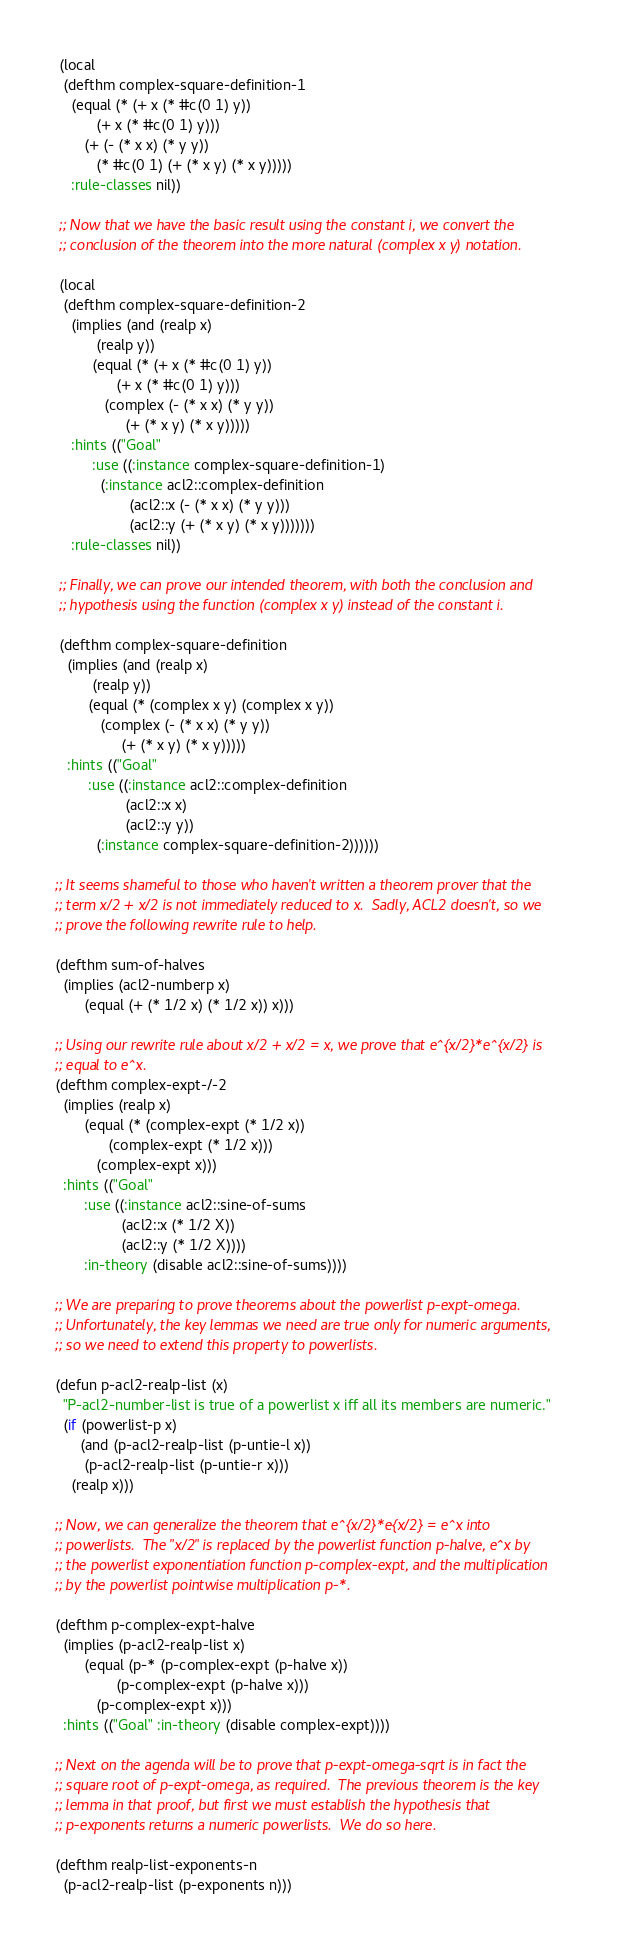<code> <loc_0><loc_0><loc_500><loc_500><_Lisp_> (local
  (defthm complex-square-definition-1
    (equal (* (+ x (* #c(0 1) y))
	      (+ x (* #c(0 1) y)))
	   (+ (- (* x x) (* y y))
	      (* #c(0 1) (+ (* x y) (* x y)))))
    :rule-classes nil))

 ;; Now that we have the basic result using the constant i, we convert the
 ;; conclusion of the theorem into the more natural (complex x y) notation.

 (local
  (defthm complex-square-definition-2
    (implies (and (realp x)
		  (realp y))
	     (equal (* (+ x (* #c(0 1) y))
		       (+ x (* #c(0 1) y)))
		    (complex (- (* x x) (* y y))
			     (+ (* x y) (* x y)))))
    :hints (("Goal"
	     :use ((:instance complex-square-definition-1)
		   (:instance acl2::complex-definition
			      (acl2::x (- (* x x) (* y y)))
			      (acl2::y (+ (* x y) (* x y)))))))
    :rule-classes nil))

 ;; Finally, we can prove our intended theorem, with both the conclusion and
 ;; hypothesis using the function (complex x y) instead of the constant i.

 (defthm complex-square-definition
   (implies (and (realp x)
		 (realp y))
	    (equal (* (complex x y) (complex x y))
		   (complex (- (* x x) (* y y))
			    (+ (* x y) (* x y)))))
   :hints (("Goal"
	    :use ((:instance acl2::complex-definition
			     (acl2::x x)
			     (acl2::y y))
		  (:instance complex-square-definition-2))))))

;; It seems shameful to those who haven't written a theorem prover that the
;; term x/2 + x/2 is not immediately reduced to x.  Sadly, ACL2 doesn't, so we
;; prove the following rewrite rule to help.

(defthm sum-of-halves
  (implies (acl2-numberp x)
	   (equal (+ (* 1/2 x) (* 1/2 x)) x)))

;; Using our rewrite rule about x/2 + x/2 = x, we prove that e^{x/2}*e^{x/2} is
;; equal to e^x.
(defthm complex-expt-/-2
  (implies (realp x)
	   (equal (* (complex-expt (* 1/2 x))
		     (complex-expt (* 1/2 x)))
		  (complex-expt x)))
  :hints (("Goal"
	   :use ((:instance acl2::sine-of-sums
			    (acl2::x (* 1/2 X))
			    (acl2::y (* 1/2 X))))
	   :in-theory (disable acl2::sine-of-sums))))

;; We are preparing to prove theorems about the powerlist p-expt-omega.
;; Unfortunately, the key lemmas we need are true only for numeric arguments,
;; so we need to extend this property to powerlists.

(defun p-acl2-realp-list (x)
  "P-acl2-number-list is true of a powerlist x iff all its members are numeric."
  (if (powerlist-p x)
      (and (p-acl2-realp-list (p-untie-l x))
	   (p-acl2-realp-list (p-untie-r x)))
    (realp x)))

;; Now, we can generalize the theorem that e^{x/2}*e{x/2} = e^x into
;; powerlists.  The "x/2" is replaced by the powerlist function p-halve, e^x by
;; the powerlist exponentiation function p-complex-expt, and the multiplication
;; by the powerlist pointwise multiplication p-*.

(defthm p-complex-expt-halve
  (implies (p-acl2-realp-list x)
	   (equal (p-* (p-complex-expt (p-halve x))
		       (p-complex-expt (p-halve x)))
		  (p-complex-expt x)))
  :hints (("Goal" :in-theory (disable complex-expt))))

;; Next on the agenda will be to prove that p-expt-omega-sqrt is in fact the
;; square root of p-expt-omega, as required.  The previous theorem is the key
;; lemma in that proof, but first we must establish the hypothesis that
;; p-exponents returns a numeric powerlists.  We do so here.

(defthm realp-list-exponents-n
  (p-acl2-realp-list (p-exponents n)))
</code> 